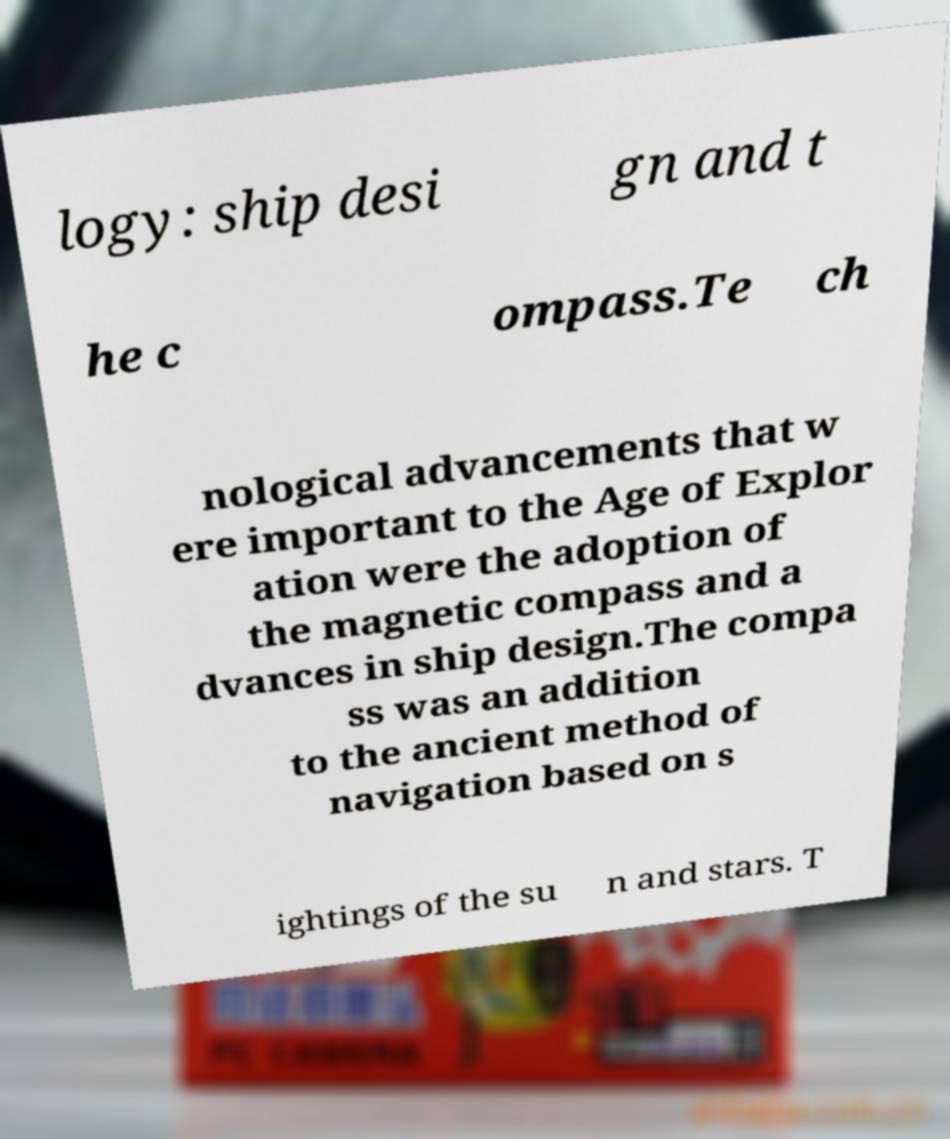For documentation purposes, I need the text within this image transcribed. Could you provide that? logy: ship desi gn and t he c ompass.Te ch nological advancements that w ere important to the Age of Explor ation were the adoption of the magnetic compass and a dvances in ship design.The compa ss was an addition to the ancient method of navigation based on s ightings of the su n and stars. T 